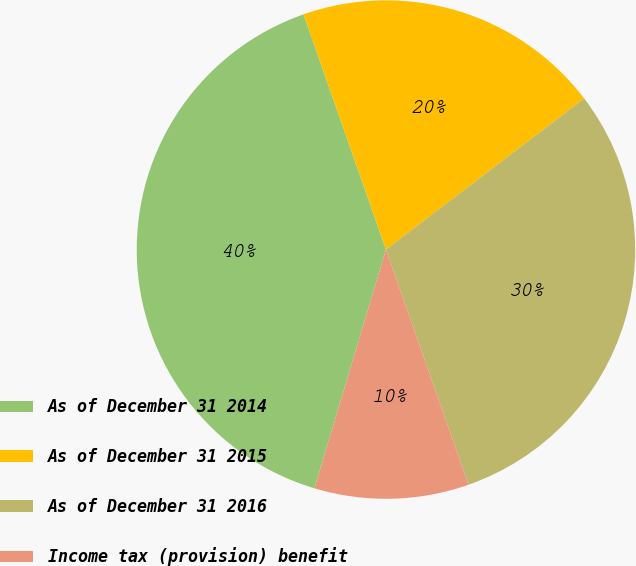Convert chart. <chart><loc_0><loc_0><loc_500><loc_500><pie_chart><fcel>As of December 31 2014<fcel>As of December 31 2015<fcel>As of December 31 2016<fcel>Income tax (provision) benefit<nl><fcel>40.0%<fcel>20.0%<fcel>30.0%<fcel>10.0%<nl></chart> 